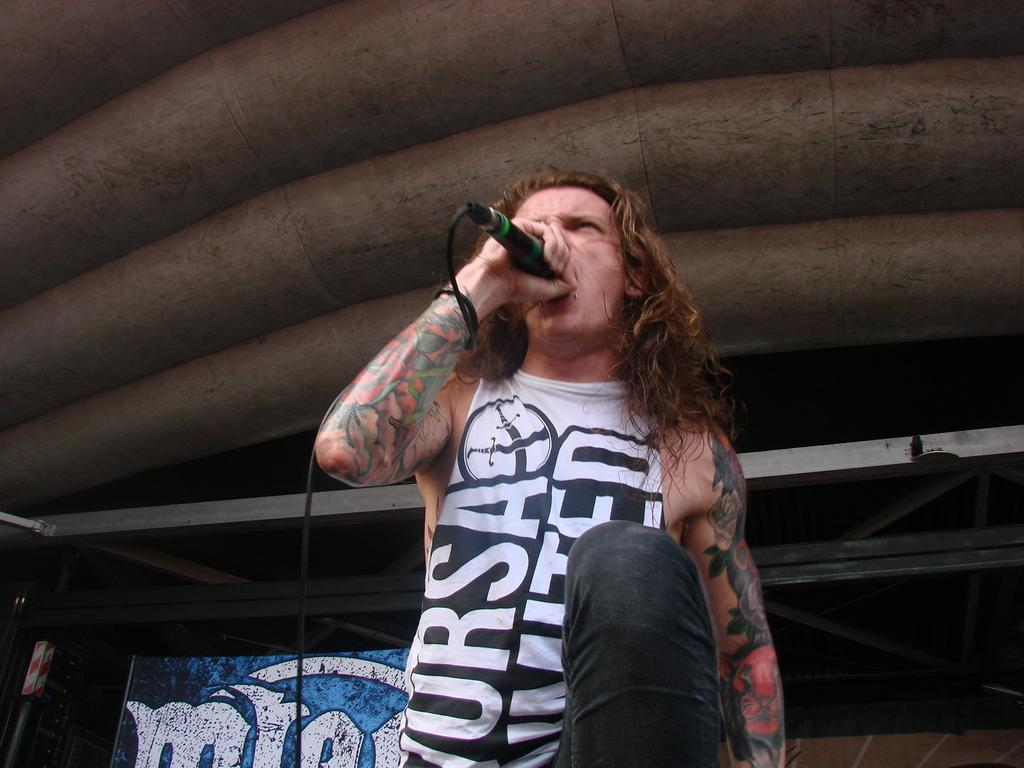What is the man in the image doing? The man is singing in the image. What is the man holding while singing? The man is holding a microphone. Can you describe any visible features on the man's hands? The man has tattoos on both hands. What type of clothing is the man wearing on his upper body? The man is wearing a t-shirt. What type of clothing is the man wearing on his lower body? The man is wearing jeans. What can be seen in the background of the image? There is a wallpaper in the background of the image. What type of punishment is the man receiving for singing in the image? There is no indication in the image that the man is receiving any punishment for singing. 